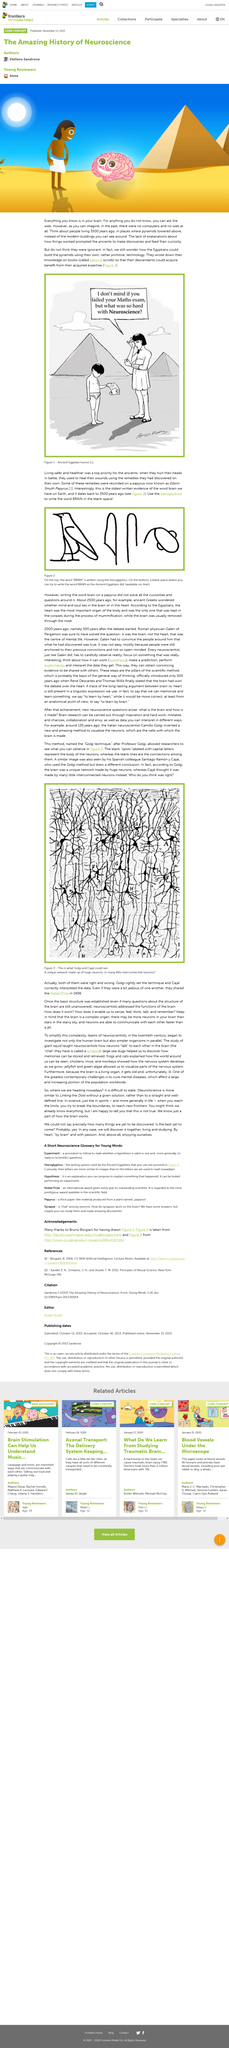Give some essential details in this illustration. The ancient people made discoveries because they were prompted by the lack of explanations. The construction of the pyramids in Egypt remains a mystery to this day, as there are still many unsolved feats associated with their building. Egyptians passed down knowledge through the use of books called papyrus, which played a crucial role in preserving and transmitting information to future generations. 